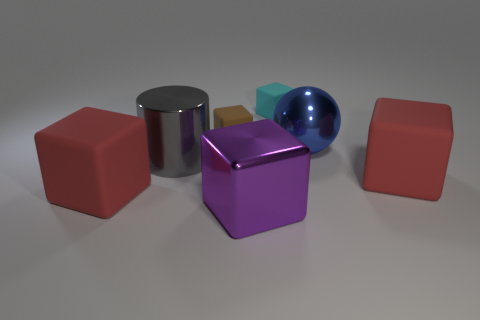What is the size of the purple object that is the same shape as the cyan thing?
Your answer should be compact. Large. What material is the big red block on the right side of the big shiny cube?
Ensure brevity in your answer.  Rubber. Are there any purple rubber cylinders of the same size as the brown cube?
Your answer should be very brief. No. Does the big purple thing have the same shape as the thing that is to the right of the big blue object?
Provide a succinct answer. Yes. There is a red matte thing to the left of the large metallic ball; does it have the same size as the metal object right of the purple thing?
Ensure brevity in your answer.  Yes. What number of other objects are the same shape as the gray object?
Provide a short and direct response. 0. There is a large cube that is to the left of the tiny block in front of the tiny cyan rubber block; what is it made of?
Offer a terse response. Rubber. What number of shiny things are either tiny gray spheres or tiny brown objects?
Provide a succinct answer. 0. Is there anything else that has the same material as the small brown thing?
Your answer should be compact. Yes. There is a large matte thing right of the large metal sphere; is there a tiny cyan thing that is on the right side of it?
Your answer should be very brief. No. 